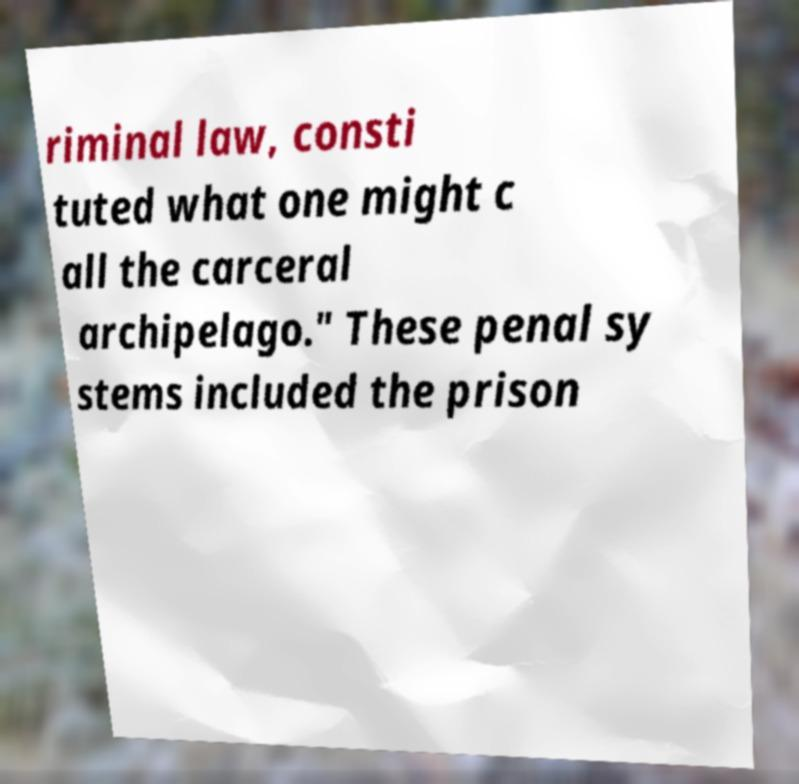Please identify and transcribe the text found in this image. riminal law, consti tuted what one might c all the carceral archipelago." These penal sy stems included the prison 